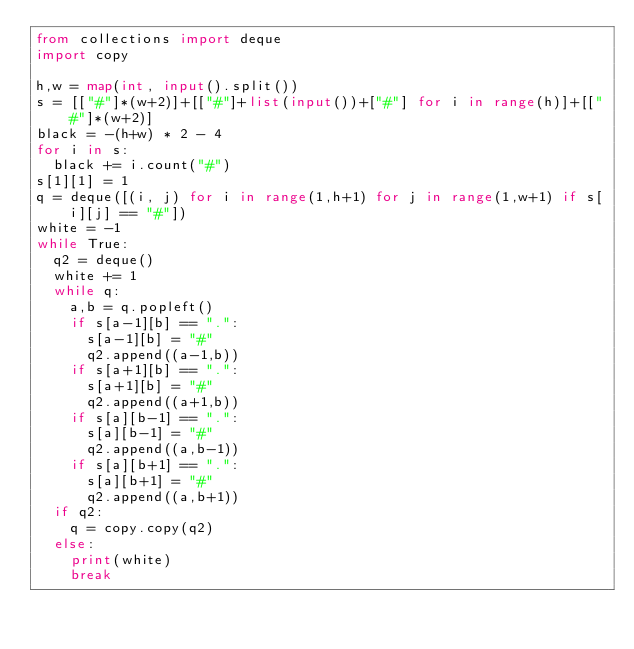<code> <loc_0><loc_0><loc_500><loc_500><_Python_>from collections import deque
import copy

h,w = map(int, input().split())
s = [["#"]*(w+2)]+[["#"]+list(input())+["#"] for i in range(h)]+[["#"]*(w+2)]
black = -(h+w) * 2 - 4
for i in s:
  black += i.count("#")
s[1][1] = 1
q = deque([(i, j) for i in range(1,h+1) for j in range(1,w+1) if s[i][j] == "#"])
white = -1
while True:
  q2 = deque()
  white += 1
  while q:
    a,b = q.popleft()
    if s[a-1][b] == ".":
      s[a-1][b] = "#"
      q2.append((a-1,b))
    if s[a+1][b] == ".":
      s[a+1][b] = "#"
      q2.append((a+1,b))
    if s[a][b-1] == ".":
      s[a][b-1] = "#"
      q2.append((a,b-1))
    if s[a][b+1] == ".":
      s[a][b+1] = "#"
      q2.append((a,b+1))   
  if q2:
    q = copy.copy(q2)
  else:
    print(white)
    break</code> 